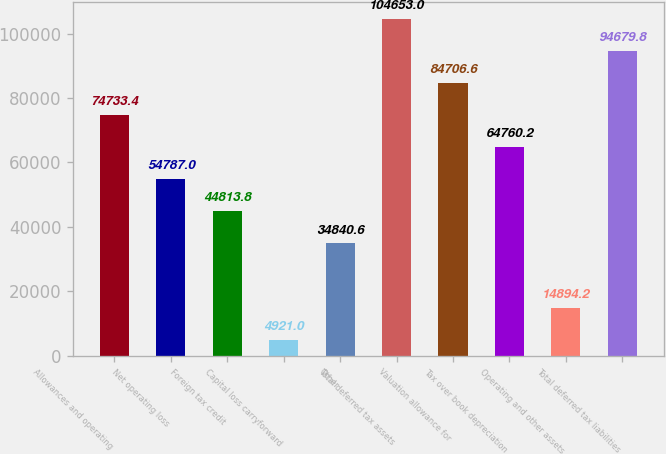Convert chart to OTSL. <chart><loc_0><loc_0><loc_500><loc_500><bar_chart><fcel>Allowances and operating<fcel>Net operating loss<fcel>Foreign tax credit<fcel>Capital loss carryforward<fcel>Other<fcel>Total deferred tax assets<fcel>Valuation allowance for<fcel>Tax over book depreciation<fcel>Operating and other assets<fcel>Total deferred tax liabilities<nl><fcel>74733.4<fcel>54787<fcel>44813.8<fcel>4921<fcel>34840.6<fcel>104653<fcel>84706.6<fcel>64760.2<fcel>14894.2<fcel>94679.8<nl></chart> 